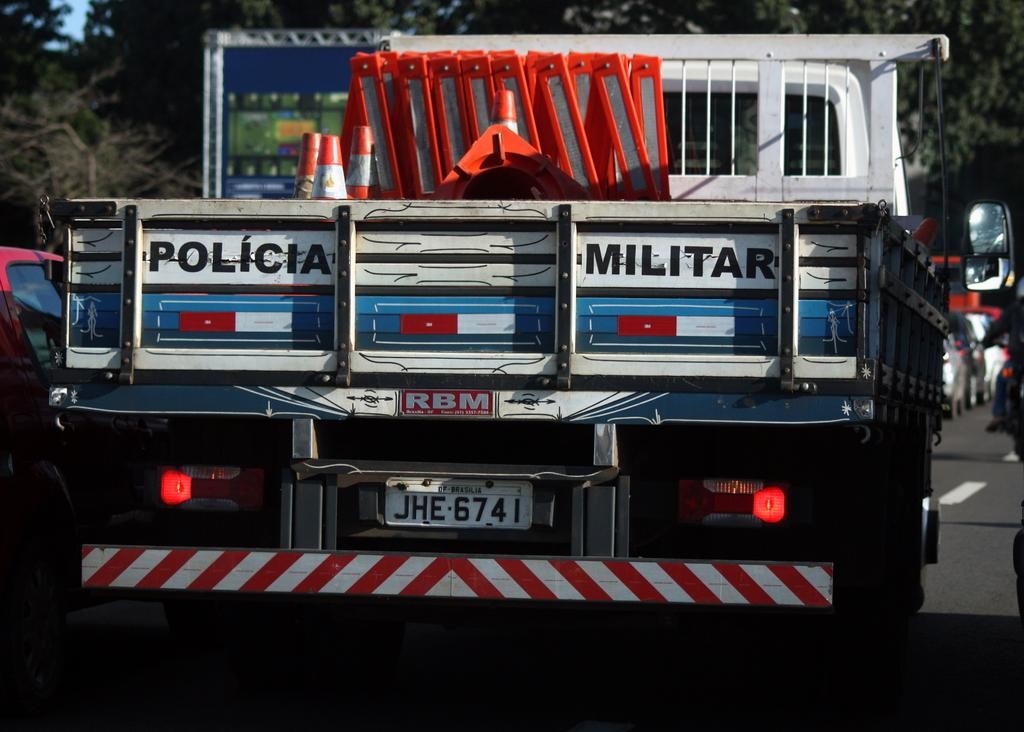What is the main vehicle in the image? There is a truck in the image. What type of natural scenery can be seen in the image? Trees are visible in the image. What else is present on the road in the image? Cars are present on the road in the image. Where is the station located in the image? There is no station present in the image. What type of wash is being performed on the truck in the image? There is no wash being performed on the truck in the image. 